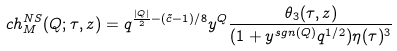<formula> <loc_0><loc_0><loc_500><loc_500>c h _ { M } ^ { N S } ( Q ; \tau , z ) = q ^ { \frac { | Q | } { 2 } - ( \tilde { c } - 1 ) / 8 } y ^ { Q } \frac { \theta _ { 3 } ( \tau , z ) } { ( 1 + y ^ { s g n ( Q ) } q ^ { 1 / 2 } ) \eta ( \tau ) ^ { 3 } }</formula> 